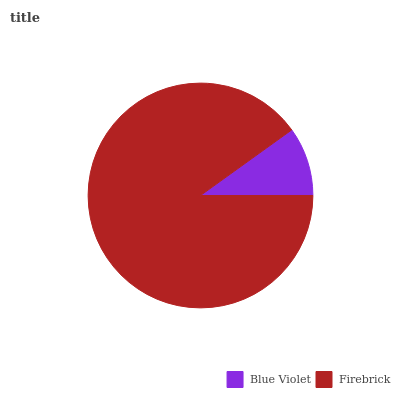Is Blue Violet the minimum?
Answer yes or no. Yes. Is Firebrick the maximum?
Answer yes or no. Yes. Is Firebrick the minimum?
Answer yes or no. No. Is Firebrick greater than Blue Violet?
Answer yes or no. Yes. Is Blue Violet less than Firebrick?
Answer yes or no. Yes. Is Blue Violet greater than Firebrick?
Answer yes or no. No. Is Firebrick less than Blue Violet?
Answer yes or no. No. Is Firebrick the high median?
Answer yes or no. Yes. Is Blue Violet the low median?
Answer yes or no. Yes. Is Blue Violet the high median?
Answer yes or no. No. Is Firebrick the low median?
Answer yes or no. No. 